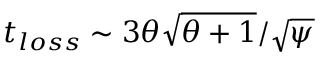Convert formula to latex. <formula><loc_0><loc_0><loc_500><loc_500>t _ { l o s s } \sim 3 \theta \sqrt { \theta + 1 } / \sqrt { \psi }</formula> 